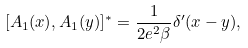Convert formula to latex. <formula><loc_0><loc_0><loc_500><loc_500>[ A _ { 1 } ( x ) , A _ { 1 } ( y ) ] ^ { * } = \frac { 1 } { 2 e ^ { 2 } \beta } \delta ^ { \prime } ( x - y ) ,</formula> 